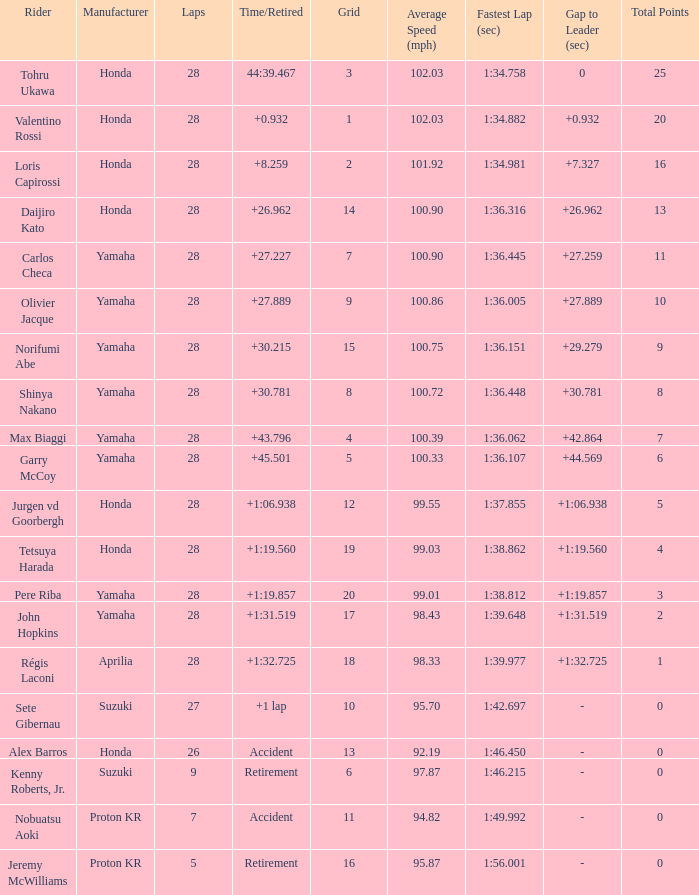How many laps were in grid 4? 28.0. 